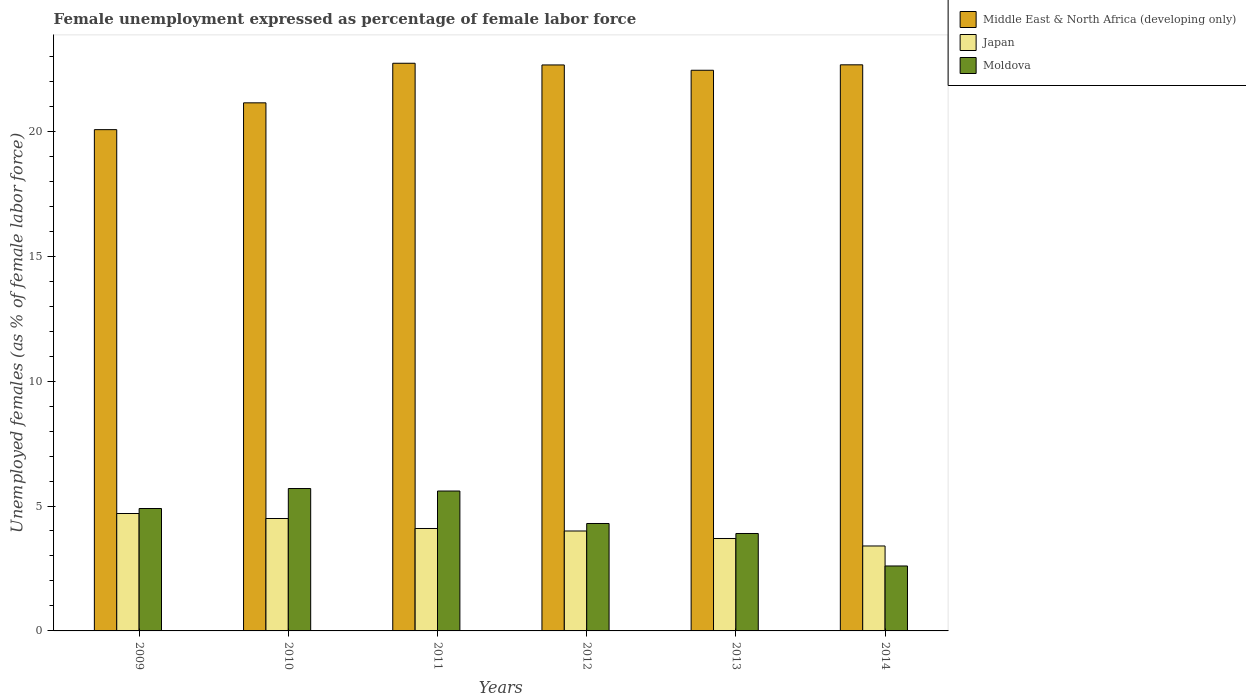How many bars are there on the 3rd tick from the left?
Make the answer very short. 3. How many bars are there on the 1st tick from the right?
Your answer should be very brief. 3. What is the unemployment in females in in Moldova in 2010?
Offer a very short reply. 5.7. Across all years, what is the maximum unemployment in females in in Japan?
Your answer should be compact. 4.7. Across all years, what is the minimum unemployment in females in in Japan?
Your response must be concise. 3.4. What is the total unemployment in females in in Moldova in the graph?
Your answer should be very brief. 27. What is the difference between the unemployment in females in in Japan in 2011 and that in 2012?
Your answer should be very brief. 0.1. What is the difference between the unemployment in females in in Moldova in 2011 and the unemployment in females in in Japan in 2010?
Offer a terse response. 1.1. What is the average unemployment in females in in Middle East & North Africa (developing only) per year?
Give a very brief answer. 21.95. In the year 2010, what is the difference between the unemployment in females in in Moldova and unemployment in females in in Middle East & North Africa (developing only)?
Make the answer very short. -15.44. In how many years, is the unemployment in females in in Moldova greater than 6 %?
Provide a succinct answer. 0. What is the ratio of the unemployment in females in in Japan in 2013 to that in 2014?
Ensure brevity in your answer.  1.09. Is the unemployment in females in in Japan in 2009 less than that in 2010?
Give a very brief answer. No. What is the difference between the highest and the second highest unemployment in females in in Moldova?
Your answer should be compact. 0.1. What is the difference between the highest and the lowest unemployment in females in in Japan?
Make the answer very short. 1.3. Is the sum of the unemployment in females in in Japan in 2013 and 2014 greater than the maximum unemployment in females in in Middle East & North Africa (developing only) across all years?
Offer a terse response. No. What does the 1st bar from the left in 2014 represents?
Your answer should be compact. Middle East & North Africa (developing only). Is it the case that in every year, the sum of the unemployment in females in in Moldova and unemployment in females in in Japan is greater than the unemployment in females in in Middle East & North Africa (developing only)?
Offer a very short reply. No. Are all the bars in the graph horizontal?
Offer a very short reply. No. Are the values on the major ticks of Y-axis written in scientific E-notation?
Your answer should be compact. No. Where does the legend appear in the graph?
Your response must be concise. Top right. What is the title of the graph?
Offer a terse response. Female unemployment expressed as percentage of female labor force. Does "American Samoa" appear as one of the legend labels in the graph?
Keep it short and to the point. No. What is the label or title of the X-axis?
Offer a terse response. Years. What is the label or title of the Y-axis?
Your response must be concise. Unemployed females (as % of female labor force). What is the Unemployed females (as % of female labor force) of Middle East & North Africa (developing only) in 2009?
Your answer should be very brief. 20.07. What is the Unemployed females (as % of female labor force) of Japan in 2009?
Your answer should be compact. 4.7. What is the Unemployed females (as % of female labor force) in Moldova in 2009?
Keep it short and to the point. 4.9. What is the Unemployed females (as % of female labor force) in Middle East & North Africa (developing only) in 2010?
Your answer should be very brief. 21.14. What is the Unemployed females (as % of female labor force) of Japan in 2010?
Give a very brief answer. 4.5. What is the Unemployed females (as % of female labor force) in Moldova in 2010?
Make the answer very short. 5.7. What is the Unemployed females (as % of female labor force) of Middle East & North Africa (developing only) in 2011?
Offer a terse response. 22.72. What is the Unemployed females (as % of female labor force) in Japan in 2011?
Ensure brevity in your answer.  4.1. What is the Unemployed females (as % of female labor force) in Moldova in 2011?
Provide a short and direct response. 5.6. What is the Unemployed females (as % of female labor force) in Middle East & North Africa (developing only) in 2012?
Your response must be concise. 22.66. What is the Unemployed females (as % of female labor force) of Moldova in 2012?
Your answer should be very brief. 4.3. What is the Unemployed females (as % of female labor force) in Middle East & North Africa (developing only) in 2013?
Ensure brevity in your answer.  22.44. What is the Unemployed females (as % of female labor force) of Japan in 2013?
Provide a short and direct response. 3.7. What is the Unemployed females (as % of female labor force) of Moldova in 2013?
Offer a terse response. 3.9. What is the Unemployed females (as % of female labor force) of Middle East & North Africa (developing only) in 2014?
Your answer should be compact. 22.66. What is the Unemployed females (as % of female labor force) of Japan in 2014?
Your answer should be compact. 3.4. What is the Unemployed females (as % of female labor force) in Moldova in 2014?
Your answer should be compact. 2.6. Across all years, what is the maximum Unemployed females (as % of female labor force) of Middle East & North Africa (developing only)?
Your answer should be very brief. 22.72. Across all years, what is the maximum Unemployed females (as % of female labor force) in Japan?
Your answer should be compact. 4.7. Across all years, what is the maximum Unemployed females (as % of female labor force) in Moldova?
Your answer should be very brief. 5.7. Across all years, what is the minimum Unemployed females (as % of female labor force) of Middle East & North Africa (developing only)?
Your answer should be very brief. 20.07. Across all years, what is the minimum Unemployed females (as % of female labor force) of Japan?
Ensure brevity in your answer.  3.4. Across all years, what is the minimum Unemployed females (as % of female labor force) in Moldova?
Ensure brevity in your answer.  2.6. What is the total Unemployed females (as % of female labor force) in Middle East & North Africa (developing only) in the graph?
Offer a very short reply. 131.69. What is the total Unemployed females (as % of female labor force) of Japan in the graph?
Your response must be concise. 24.4. What is the difference between the Unemployed females (as % of female labor force) in Middle East & North Africa (developing only) in 2009 and that in 2010?
Make the answer very short. -1.07. What is the difference between the Unemployed females (as % of female labor force) of Middle East & North Africa (developing only) in 2009 and that in 2011?
Your answer should be very brief. -2.66. What is the difference between the Unemployed females (as % of female labor force) in Japan in 2009 and that in 2011?
Your response must be concise. 0.6. What is the difference between the Unemployed females (as % of female labor force) in Middle East & North Africa (developing only) in 2009 and that in 2012?
Give a very brief answer. -2.59. What is the difference between the Unemployed females (as % of female labor force) of Japan in 2009 and that in 2012?
Your answer should be compact. 0.7. What is the difference between the Unemployed females (as % of female labor force) of Moldova in 2009 and that in 2012?
Offer a terse response. 0.6. What is the difference between the Unemployed females (as % of female labor force) of Middle East & North Africa (developing only) in 2009 and that in 2013?
Ensure brevity in your answer.  -2.38. What is the difference between the Unemployed females (as % of female labor force) in Middle East & North Africa (developing only) in 2009 and that in 2014?
Ensure brevity in your answer.  -2.6. What is the difference between the Unemployed females (as % of female labor force) of Japan in 2009 and that in 2014?
Provide a succinct answer. 1.3. What is the difference between the Unemployed females (as % of female labor force) in Middle East & North Africa (developing only) in 2010 and that in 2011?
Provide a succinct answer. -1.58. What is the difference between the Unemployed females (as % of female labor force) in Moldova in 2010 and that in 2011?
Keep it short and to the point. 0.1. What is the difference between the Unemployed females (as % of female labor force) of Middle East & North Africa (developing only) in 2010 and that in 2012?
Provide a short and direct response. -1.52. What is the difference between the Unemployed females (as % of female labor force) in Japan in 2010 and that in 2012?
Provide a short and direct response. 0.5. What is the difference between the Unemployed females (as % of female labor force) in Middle East & North Africa (developing only) in 2010 and that in 2013?
Provide a short and direct response. -1.3. What is the difference between the Unemployed females (as % of female labor force) in Middle East & North Africa (developing only) in 2010 and that in 2014?
Keep it short and to the point. -1.52. What is the difference between the Unemployed females (as % of female labor force) of Japan in 2010 and that in 2014?
Your answer should be compact. 1.1. What is the difference between the Unemployed females (as % of female labor force) in Middle East & North Africa (developing only) in 2011 and that in 2012?
Offer a terse response. 0.07. What is the difference between the Unemployed females (as % of female labor force) in Japan in 2011 and that in 2012?
Provide a succinct answer. 0.1. What is the difference between the Unemployed females (as % of female labor force) in Moldova in 2011 and that in 2012?
Ensure brevity in your answer.  1.3. What is the difference between the Unemployed females (as % of female labor force) of Middle East & North Africa (developing only) in 2011 and that in 2013?
Offer a very short reply. 0.28. What is the difference between the Unemployed females (as % of female labor force) in Middle East & North Africa (developing only) in 2011 and that in 2014?
Your answer should be very brief. 0.06. What is the difference between the Unemployed females (as % of female labor force) in Japan in 2011 and that in 2014?
Make the answer very short. 0.7. What is the difference between the Unemployed females (as % of female labor force) in Middle East & North Africa (developing only) in 2012 and that in 2013?
Provide a succinct answer. 0.21. What is the difference between the Unemployed females (as % of female labor force) in Japan in 2012 and that in 2013?
Your answer should be compact. 0.3. What is the difference between the Unemployed females (as % of female labor force) of Middle East & North Africa (developing only) in 2012 and that in 2014?
Your answer should be compact. -0.01. What is the difference between the Unemployed females (as % of female labor force) in Japan in 2012 and that in 2014?
Provide a succinct answer. 0.6. What is the difference between the Unemployed females (as % of female labor force) of Middle East & North Africa (developing only) in 2013 and that in 2014?
Your answer should be very brief. -0.22. What is the difference between the Unemployed females (as % of female labor force) in Moldova in 2013 and that in 2014?
Ensure brevity in your answer.  1.3. What is the difference between the Unemployed females (as % of female labor force) in Middle East & North Africa (developing only) in 2009 and the Unemployed females (as % of female labor force) in Japan in 2010?
Provide a short and direct response. 15.57. What is the difference between the Unemployed females (as % of female labor force) in Middle East & North Africa (developing only) in 2009 and the Unemployed females (as % of female labor force) in Moldova in 2010?
Offer a terse response. 14.37. What is the difference between the Unemployed females (as % of female labor force) in Middle East & North Africa (developing only) in 2009 and the Unemployed females (as % of female labor force) in Japan in 2011?
Provide a short and direct response. 15.97. What is the difference between the Unemployed females (as % of female labor force) of Middle East & North Africa (developing only) in 2009 and the Unemployed females (as % of female labor force) of Moldova in 2011?
Provide a short and direct response. 14.47. What is the difference between the Unemployed females (as % of female labor force) in Japan in 2009 and the Unemployed females (as % of female labor force) in Moldova in 2011?
Offer a very short reply. -0.9. What is the difference between the Unemployed females (as % of female labor force) of Middle East & North Africa (developing only) in 2009 and the Unemployed females (as % of female labor force) of Japan in 2012?
Offer a terse response. 16.07. What is the difference between the Unemployed females (as % of female labor force) in Middle East & North Africa (developing only) in 2009 and the Unemployed females (as % of female labor force) in Moldova in 2012?
Offer a terse response. 15.77. What is the difference between the Unemployed females (as % of female labor force) in Japan in 2009 and the Unemployed females (as % of female labor force) in Moldova in 2012?
Offer a terse response. 0.4. What is the difference between the Unemployed females (as % of female labor force) of Middle East & North Africa (developing only) in 2009 and the Unemployed females (as % of female labor force) of Japan in 2013?
Your response must be concise. 16.37. What is the difference between the Unemployed females (as % of female labor force) in Middle East & North Africa (developing only) in 2009 and the Unemployed females (as % of female labor force) in Moldova in 2013?
Your answer should be compact. 16.17. What is the difference between the Unemployed females (as % of female labor force) in Japan in 2009 and the Unemployed females (as % of female labor force) in Moldova in 2013?
Provide a succinct answer. 0.8. What is the difference between the Unemployed females (as % of female labor force) of Middle East & North Africa (developing only) in 2009 and the Unemployed females (as % of female labor force) of Japan in 2014?
Give a very brief answer. 16.67. What is the difference between the Unemployed females (as % of female labor force) of Middle East & North Africa (developing only) in 2009 and the Unemployed females (as % of female labor force) of Moldova in 2014?
Your answer should be compact. 17.47. What is the difference between the Unemployed females (as % of female labor force) in Japan in 2009 and the Unemployed females (as % of female labor force) in Moldova in 2014?
Your answer should be very brief. 2.1. What is the difference between the Unemployed females (as % of female labor force) of Middle East & North Africa (developing only) in 2010 and the Unemployed females (as % of female labor force) of Japan in 2011?
Ensure brevity in your answer.  17.04. What is the difference between the Unemployed females (as % of female labor force) of Middle East & North Africa (developing only) in 2010 and the Unemployed females (as % of female labor force) of Moldova in 2011?
Provide a succinct answer. 15.54. What is the difference between the Unemployed females (as % of female labor force) in Middle East & North Africa (developing only) in 2010 and the Unemployed females (as % of female labor force) in Japan in 2012?
Provide a succinct answer. 17.14. What is the difference between the Unemployed females (as % of female labor force) in Middle East & North Africa (developing only) in 2010 and the Unemployed females (as % of female labor force) in Moldova in 2012?
Your response must be concise. 16.84. What is the difference between the Unemployed females (as % of female labor force) of Japan in 2010 and the Unemployed females (as % of female labor force) of Moldova in 2012?
Provide a succinct answer. 0.2. What is the difference between the Unemployed females (as % of female labor force) in Middle East & North Africa (developing only) in 2010 and the Unemployed females (as % of female labor force) in Japan in 2013?
Your response must be concise. 17.44. What is the difference between the Unemployed females (as % of female labor force) in Middle East & North Africa (developing only) in 2010 and the Unemployed females (as % of female labor force) in Moldova in 2013?
Your response must be concise. 17.24. What is the difference between the Unemployed females (as % of female labor force) in Middle East & North Africa (developing only) in 2010 and the Unemployed females (as % of female labor force) in Japan in 2014?
Your answer should be very brief. 17.74. What is the difference between the Unemployed females (as % of female labor force) in Middle East & North Africa (developing only) in 2010 and the Unemployed females (as % of female labor force) in Moldova in 2014?
Your answer should be compact. 18.54. What is the difference between the Unemployed females (as % of female labor force) of Japan in 2010 and the Unemployed females (as % of female labor force) of Moldova in 2014?
Provide a short and direct response. 1.9. What is the difference between the Unemployed females (as % of female labor force) in Middle East & North Africa (developing only) in 2011 and the Unemployed females (as % of female labor force) in Japan in 2012?
Ensure brevity in your answer.  18.72. What is the difference between the Unemployed females (as % of female labor force) of Middle East & North Africa (developing only) in 2011 and the Unemployed females (as % of female labor force) of Moldova in 2012?
Keep it short and to the point. 18.42. What is the difference between the Unemployed females (as % of female labor force) in Middle East & North Africa (developing only) in 2011 and the Unemployed females (as % of female labor force) in Japan in 2013?
Give a very brief answer. 19.02. What is the difference between the Unemployed females (as % of female labor force) of Middle East & North Africa (developing only) in 2011 and the Unemployed females (as % of female labor force) of Moldova in 2013?
Your response must be concise. 18.82. What is the difference between the Unemployed females (as % of female labor force) of Middle East & North Africa (developing only) in 2011 and the Unemployed females (as % of female labor force) of Japan in 2014?
Your answer should be very brief. 19.32. What is the difference between the Unemployed females (as % of female labor force) of Middle East & North Africa (developing only) in 2011 and the Unemployed females (as % of female labor force) of Moldova in 2014?
Provide a short and direct response. 20.12. What is the difference between the Unemployed females (as % of female labor force) of Japan in 2011 and the Unemployed females (as % of female labor force) of Moldova in 2014?
Your response must be concise. 1.5. What is the difference between the Unemployed females (as % of female labor force) of Middle East & North Africa (developing only) in 2012 and the Unemployed females (as % of female labor force) of Japan in 2013?
Your answer should be compact. 18.96. What is the difference between the Unemployed females (as % of female labor force) of Middle East & North Africa (developing only) in 2012 and the Unemployed females (as % of female labor force) of Moldova in 2013?
Keep it short and to the point. 18.76. What is the difference between the Unemployed females (as % of female labor force) in Japan in 2012 and the Unemployed females (as % of female labor force) in Moldova in 2013?
Offer a terse response. 0.1. What is the difference between the Unemployed females (as % of female labor force) of Middle East & North Africa (developing only) in 2012 and the Unemployed females (as % of female labor force) of Japan in 2014?
Give a very brief answer. 19.26. What is the difference between the Unemployed females (as % of female labor force) in Middle East & North Africa (developing only) in 2012 and the Unemployed females (as % of female labor force) in Moldova in 2014?
Provide a succinct answer. 20.06. What is the difference between the Unemployed females (as % of female labor force) in Japan in 2012 and the Unemployed females (as % of female labor force) in Moldova in 2014?
Your answer should be very brief. 1.4. What is the difference between the Unemployed females (as % of female labor force) of Middle East & North Africa (developing only) in 2013 and the Unemployed females (as % of female labor force) of Japan in 2014?
Keep it short and to the point. 19.04. What is the difference between the Unemployed females (as % of female labor force) in Middle East & North Africa (developing only) in 2013 and the Unemployed females (as % of female labor force) in Moldova in 2014?
Offer a terse response. 19.84. What is the difference between the Unemployed females (as % of female labor force) of Japan in 2013 and the Unemployed females (as % of female labor force) of Moldova in 2014?
Ensure brevity in your answer.  1.1. What is the average Unemployed females (as % of female labor force) of Middle East & North Africa (developing only) per year?
Make the answer very short. 21.95. What is the average Unemployed females (as % of female labor force) of Japan per year?
Provide a short and direct response. 4.07. What is the average Unemployed females (as % of female labor force) in Moldova per year?
Make the answer very short. 4.5. In the year 2009, what is the difference between the Unemployed females (as % of female labor force) in Middle East & North Africa (developing only) and Unemployed females (as % of female labor force) in Japan?
Make the answer very short. 15.37. In the year 2009, what is the difference between the Unemployed females (as % of female labor force) of Middle East & North Africa (developing only) and Unemployed females (as % of female labor force) of Moldova?
Make the answer very short. 15.17. In the year 2009, what is the difference between the Unemployed females (as % of female labor force) in Japan and Unemployed females (as % of female labor force) in Moldova?
Offer a terse response. -0.2. In the year 2010, what is the difference between the Unemployed females (as % of female labor force) in Middle East & North Africa (developing only) and Unemployed females (as % of female labor force) in Japan?
Offer a very short reply. 16.64. In the year 2010, what is the difference between the Unemployed females (as % of female labor force) in Middle East & North Africa (developing only) and Unemployed females (as % of female labor force) in Moldova?
Ensure brevity in your answer.  15.44. In the year 2010, what is the difference between the Unemployed females (as % of female labor force) of Japan and Unemployed females (as % of female labor force) of Moldova?
Give a very brief answer. -1.2. In the year 2011, what is the difference between the Unemployed females (as % of female labor force) of Middle East & North Africa (developing only) and Unemployed females (as % of female labor force) of Japan?
Offer a very short reply. 18.62. In the year 2011, what is the difference between the Unemployed females (as % of female labor force) of Middle East & North Africa (developing only) and Unemployed females (as % of female labor force) of Moldova?
Ensure brevity in your answer.  17.12. In the year 2012, what is the difference between the Unemployed females (as % of female labor force) in Middle East & North Africa (developing only) and Unemployed females (as % of female labor force) in Japan?
Your answer should be compact. 18.66. In the year 2012, what is the difference between the Unemployed females (as % of female labor force) of Middle East & North Africa (developing only) and Unemployed females (as % of female labor force) of Moldova?
Offer a very short reply. 18.36. In the year 2013, what is the difference between the Unemployed females (as % of female labor force) in Middle East & North Africa (developing only) and Unemployed females (as % of female labor force) in Japan?
Ensure brevity in your answer.  18.74. In the year 2013, what is the difference between the Unemployed females (as % of female labor force) in Middle East & North Africa (developing only) and Unemployed females (as % of female labor force) in Moldova?
Provide a succinct answer. 18.54. In the year 2014, what is the difference between the Unemployed females (as % of female labor force) of Middle East & North Africa (developing only) and Unemployed females (as % of female labor force) of Japan?
Give a very brief answer. 19.26. In the year 2014, what is the difference between the Unemployed females (as % of female labor force) in Middle East & North Africa (developing only) and Unemployed females (as % of female labor force) in Moldova?
Give a very brief answer. 20.06. In the year 2014, what is the difference between the Unemployed females (as % of female labor force) of Japan and Unemployed females (as % of female labor force) of Moldova?
Give a very brief answer. 0.8. What is the ratio of the Unemployed females (as % of female labor force) of Middle East & North Africa (developing only) in 2009 to that in 2010?
Your answer should be compact. 0.95. What is the ratio of the Unemployed females (as % of female labor force) of Japan in 2009 to that in 2010?
Your answer should be compact. 1.04. What is the ratio of the Unemployed females (as % of female labor force) of Moldova in 2009 to that in 2010?
Ensure brevity in your answer.  0.86. What is the ratio of the Unemployed females (as % of female labor force) in Middle East & North Africa (developing only) in 2009 to that in 2011?
Provide a succinct answer. 0.88. What is the ratio of the Unemployed females (as % of female labor force) in Japan in 2009 to that in 2011?
Your answer should be compact. 1.15. What is the ratio of the Unemployed females (as % of female labor force) of Middle East & North Africa (developing only) in 2009 to that in 2012?
Provide a succinct answer. 0.89. What is the ratio of the Unemployed females (as % of female labor force) in Japan in 2009 to that in 2012?
Give a very brief answer. 1.18. What is the ratio of the Unemployed females (as % of female labor force) in Moldova in 2009 to that in 2012?
Provide a succinct answer. 1.14. What is the ratio of the Unemployed females (as % of female labor force) in Middle East & North Africa (developing only) in 2009 to that in 2013?
Provide a succinct answer. 0.89. What is the ratio of the Unemployed females (as % of female labor force) in Japan in 2009 to that in 2013?
Provide a short and direct response. 1.27. What is the ratio of the Unemployed females (as % of female labor force) of Moldova in 2009 to that in 2013?
Give a very brief answer. 1.26. What is the ratio of the Unemployed females (as % of female labor force) in Middle East & North Africa (developing only) in 2009 to that in 2014?
Ensure brevity in your answer.  0.89. What is the ratio of the Unemployed females (as % of female labor force) in Japan in 2009 to that in 2014?
Give a very brief answer. 1.38. What is the ratio of the Unemployed females (as % of female labor force) in Moldova in 2009 to that in 2014?
Keep it short and to the point. 1.88. What is the ratio of the Unemployed females (as % of female labor force) of Middle East & North Africa (developing only) in 2010 to that in 2011?
Your response must be concise. 0.93. What is the ratio of the Unemployed females (as % of female labor force) of Japan in 2010 to that in 2011?
Offer a terse response. 1.1. What is the ratio of the Unemployed females (as % of female labor force) of Moldova in 2010 to that in 2011?
Your answer should be compact. 1.02. What is the ratio of the Unemployed females (as % of female labor force) in Middle East & North Africa (developing only) in 2010 to that in 2012?
Offer a terse response. 0.93. What is the ratio of the Unemployed females (as % of female labor force) in Moldova in 2010 to that in 2012?
Offer a very short reply. 1.33. What is the ratio of the Unemployed females (as % of female labor force) of Middle East & North Africa (developing only) in 2010 to that in 2013?
Provide a short and direct response. 0.94. What is the ratio of the Unemployed females (as % of female labor force) of Japan in 2010 to that in 2013?
Your answer should be compact. 1.22. What is the ratio of the Unemployed females (as % of female labor force) in Moldova in 2010 to that in 2013?
Give a very brief answer. 1.46. What is the ratio of the Unemployed females (as % of female labor force) in Middle East & North Africa (developing only) in 2010 to that in 2014?
Your response must be concise. 0.93. What is the ratio of the Unemployed females (as % of female labor force) of Japan in 2010 to that in 2014?
Keep it short and to the point. 1.32. What is the ratio of the Unemployed females (as % of female labor force) of Moldova in 2010 to that in 2014?
Offer a very short reply. 2.19. What is the ratio of the Unemployed females (as % of female labor force) in Moldova in 2011 to that in 2012?
Give a very brief answer. 1.3. What is the ratio of the Unemployed females (as % of female labor force) in Middle East & North Africa (developing only) in 2011 to that in 2013?
Your response must be concise. 1.01. What is the ratio of the Unemployed females (as % of female labor force) in Japan in 2011 to that in 2013?
Ensure brevity in your answer.  1.11. What is the ratio of the Unemployed females (as % of female labor force) in Moldova in 2011 to that in 2013?
Your response must be concise. 1.44. What is the ratio of the Unemployed females (as % of female labor force) in Middle East & North Africa (developing only) in 2011 to that in 2014?
Give a very brief answer. 1. What is the ratio of the Unemployed females (as % of female labor force) in Japan in 2011 to that in 2014?
Offer a terse response. 1.21. What is the ratio of the Unemployed females (as % of female labor force) in Moldova in 2011 to that in 2014?
Keep it short and to the point. 2.15. What is the ratio of the Unemployed females (as % of female labor force) of Middle East & North Africa (developing only) in 2012 to that in 2013?
Offer a very short reply. 1.01. What is the ratio of the Unemployed females (as % of female labor force) in Japan in 2012 to that in 2013?
Offer a terse response. 1.08. What is the ratio of the Unemployed females (as % of female labor force) in Moldova in 2012 to that in 2013?
Your answer should be very brief. 1.1. What is the ratio of the Unemployed females (as % of female labor force) of Middle East & North Africa (developing only) in 2012 to that in 2014?
Give a very brief answer. 1. What is the ratio of the Unemployed females (as % of female labor force) in Japan in 2012 to that in 2014?
Your response must be concise. 1.18. What is the ratio of the Unemployed females (as % of female labor force) in Moldova in 2012 to that in 2014?
Make the answer very short. 1.65. What is the ratio of the Unemployed females (as % of female labor force) of Middle East & North Africa (developing only) in 2013 to that in 2014?
Keep it short and to the point. 0.99. What is the ratio of the Unemployed females (as % of female labor force) of Japan in 2013 to that in 2014?
Make the answer very short. 1.09. What is the difference between the highest and the second highest Unemployed females (as % of female labor force) in Middle East & North Africa (developing only)?
Keep it short and to the point. 0.06. What is the difference between the highest and the second highest Unemployed females (as % of female labor force) in Moldova?
Offer a very short reply. 0.1. What is the difference between the highest and the lowest Unemployed females (as % of female labor force) in Middle East & North Africa (developing only)?
Give a very brief answer. 2.66. What is the difference between the highest and the lowest Unemployed females (as % of female labor force) of Japan?
Provide a succinct answer. 1.3. 